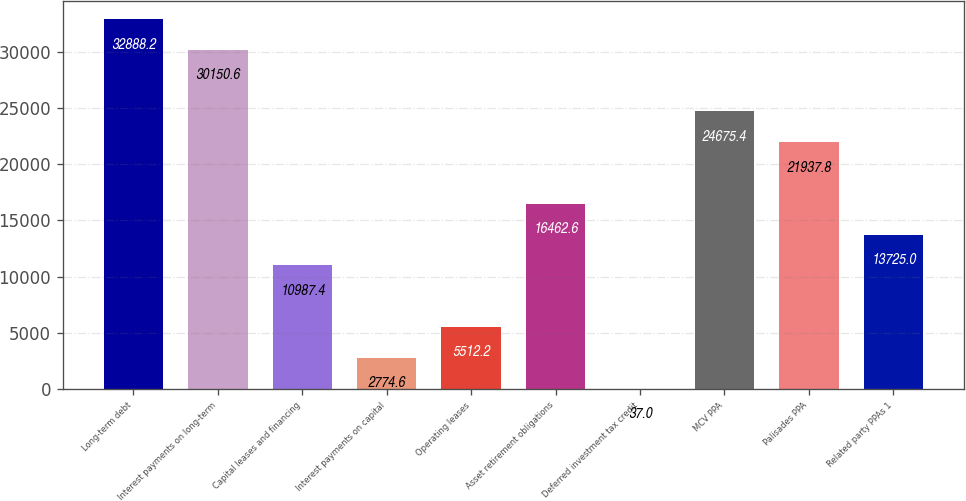<chart> <loc_0><loc_0><loc_500><loc_500><bar_chart><fcel>Long-term debt<fcel>Interest payments on long-term<fcel>Capital leases and financing<fcel>Interest payments on capital<fcel>Operating leases<fcel>Asset retirement obligations<fcel>Deferred investment tax credit<fcel>MCV PPA<fcel>Palisades PPA<fcel>Related party PPAs 1<nl><fcel>32888.2<fcel>30150.6<fcel>10987.4<fcel>2774.6<fcel>5512.2<fcel>16462.6<fcel>37<fcel>24675.4<fcel>21937.8<fcel>13725<nl></chart> 